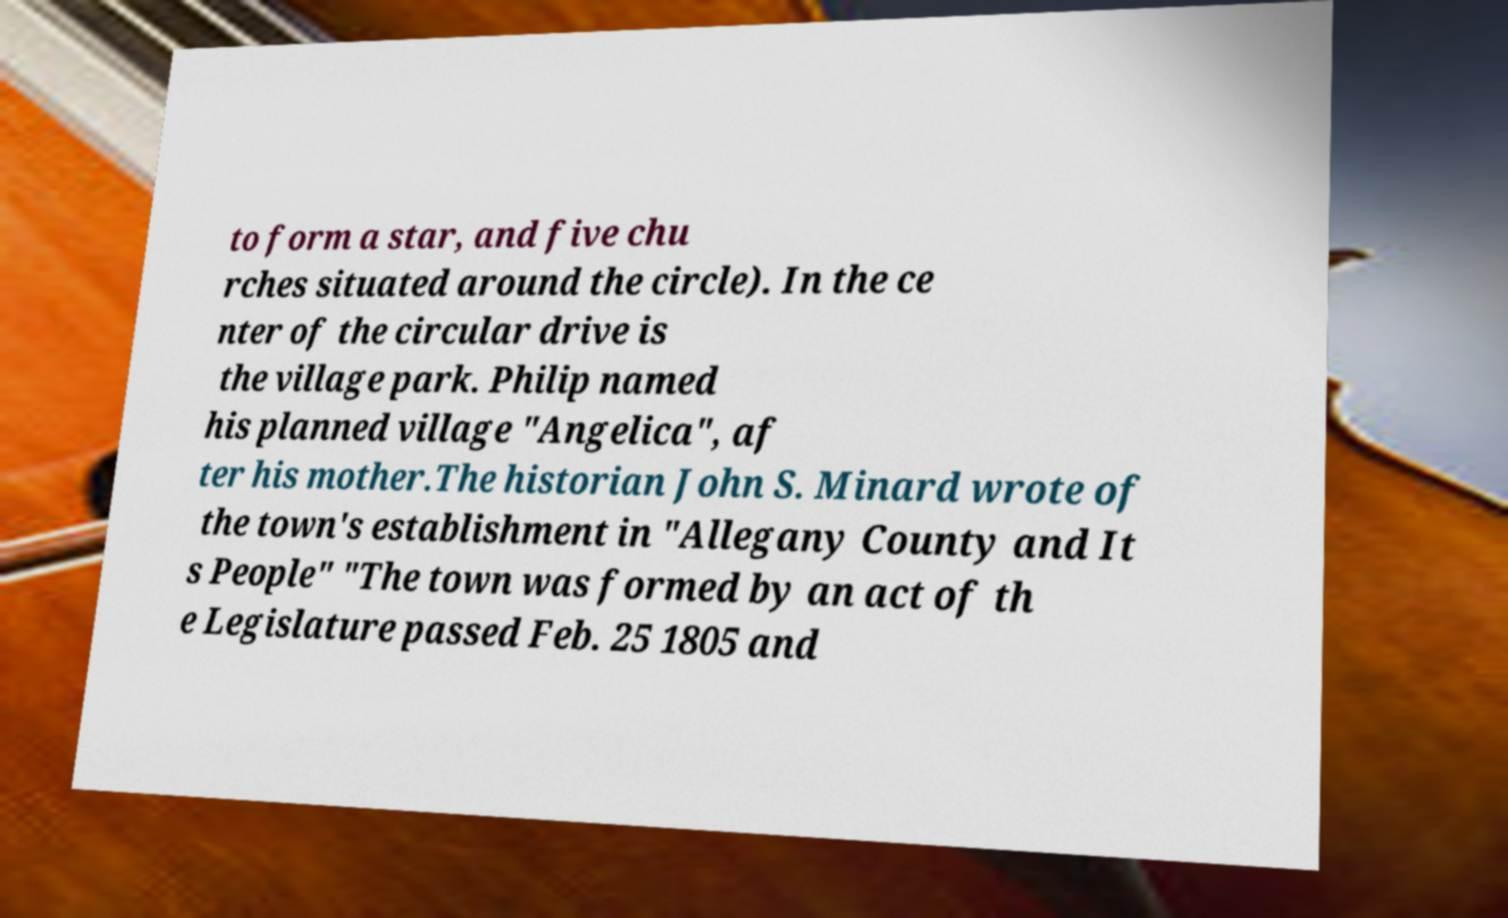What messages or text are displayed in this image? I need them in a readable, typed format. to form a star, and five chu rches situated around the circle). In the ce nter of the circular drive is the village park. Philip named his planned village "Angelica", af ter his mother.The historian John S. Minard wrote of the town's establishment in "Allegany County and It s People" "The town was formed by an act of th e Legislature passed Feb. 25 1805 and 